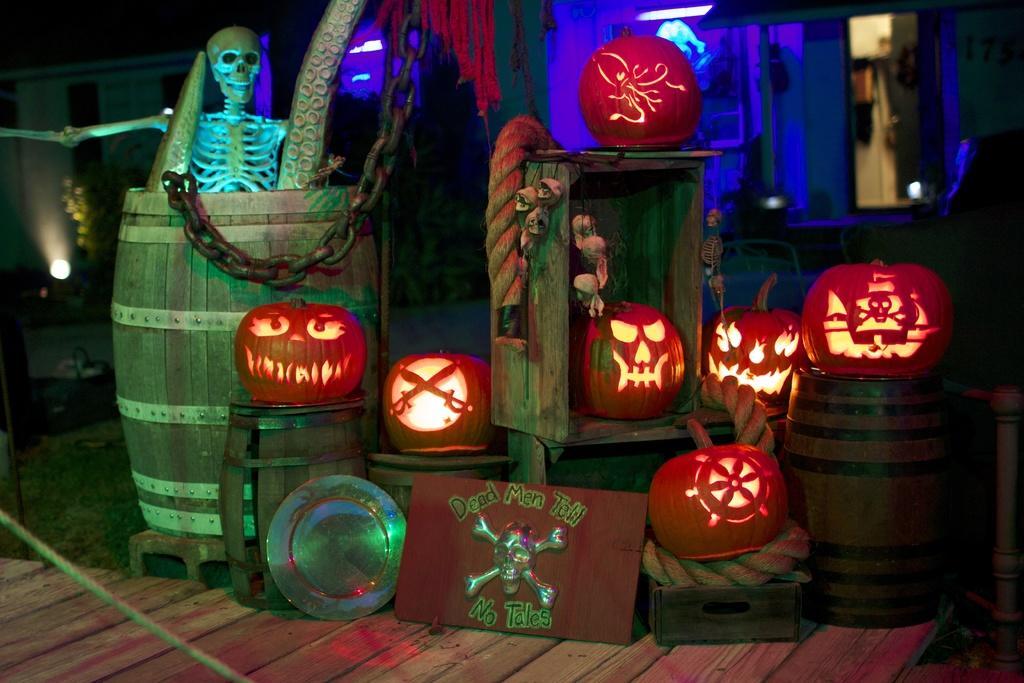In one or two sentences, can you explain what this image depicts? In the middle of the image we can see some banners, skulls, pumpkins and there are some objects. Behind them there are some lights. 